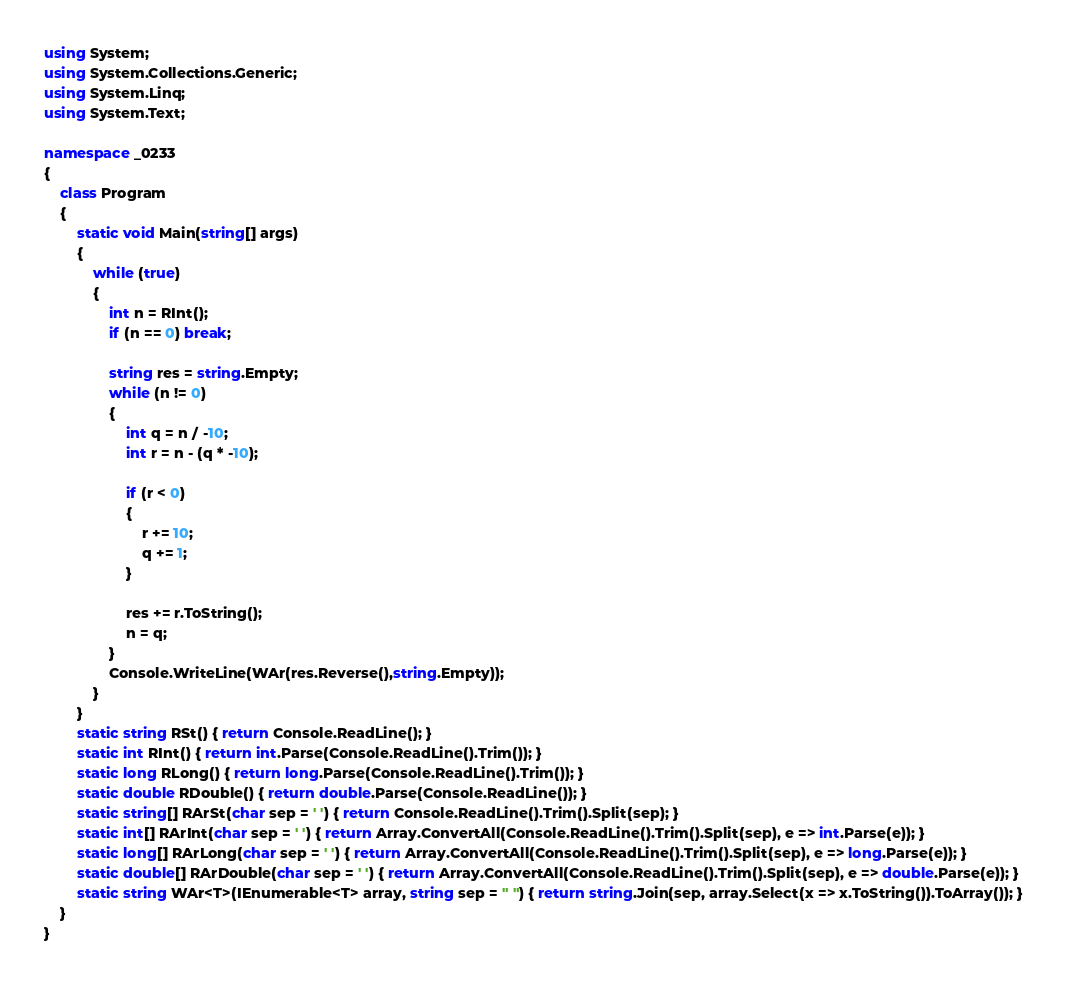Convert code to text. <code><loc_0><loc_0><loc_500><loc_500><_C#_>using System;
using System.Collections.Generic;
using System.Linq;
using System.Text;

namespace _0233
{
    class Program
    {
        static void Main(string[] args)
        {
            while (true)
            {
                int n = RInt();
                if (n == 0) break;

                string res = string.Empty;
                while (n != 0)
                {
                    int q = n / -10;
                    int r = n - (q * -10);

                    if (r < 0)
                    {
                        r += 10;
                        q += 1;
                    }

                    res += r.ToString();
                    n = q;
                }
                Console.WriteLine(WAr(res.Reverse(),string.Empty));
            }
        }
        static string RSt() { return Console.ReadLine(); }
        static int RInt() { return int.Parse(Console.ReadLine().Trim()); }
        static long RLong() { return long.Parse(Console.ReadLine().Trim()); }
        static double RDouble() { return double.Parse(Console.ReadLine()); }
        static string[] RArSt(char sep = ' ') { return Console.ReadLine().Trim().Split(sep); }
        static int[] RArInt(char sep = ' ') { return Array.ConvertAll(Console.ReadLine().Trim().Split(sep), e => int.Parse(e)); }
        static long[] RArLong(char sep = ' ') { return Array.ConvertAll(Console.ReadLine().Trim().Split(sep), e => long.Parse(e)); }
        static double[] RArDouble(char sep = ' ') { return Array.ConvertAll(Console.ReadLine().Trim().Split(sep), e => double.Parse(e)); }
        static string WAr<T>(IEnumerable<T> array, string sep = " ") { return string.Join(sep, array.Select(x => x.ToString()).ToArray()); }
    }
}

</code> 